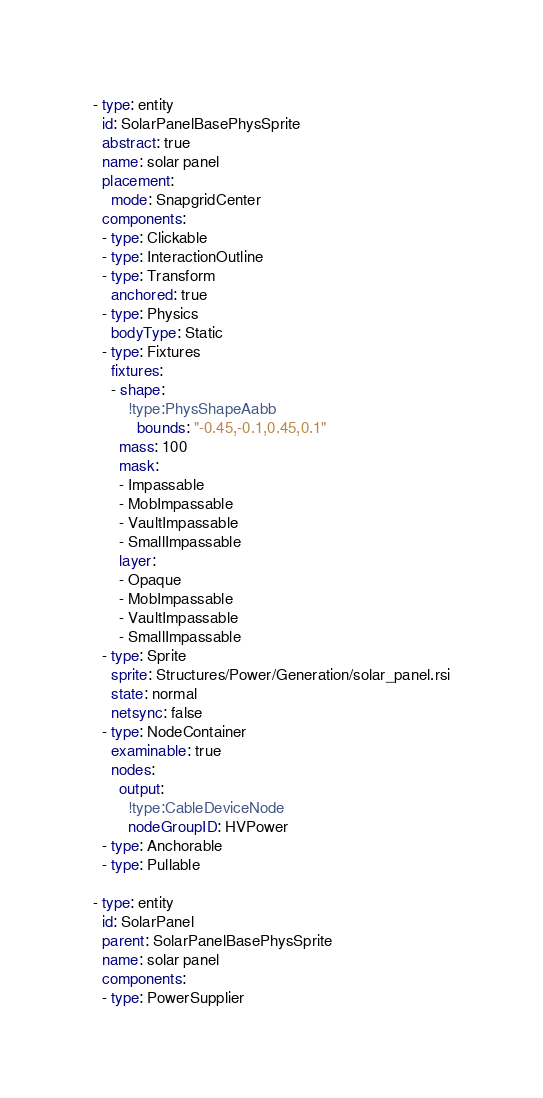<code> <loc_0><loc_0><loc_500><loc_500><_YAML_>- type: entity
  id: SolarPanelBasePhysSprite
  abstract: true
  name: solar panel
  placement:
    mode: SnapgridCenter
  components:
  - type: Clickable
  - type: InteractionOutline
  - type: Transform
    anchored: true
  - type: Physics
    bodyType: Static
  - type: Fixtures
    fixtures:
    - shape:
        !type:PhysShapeAabb
          bounds: "-0.45,-0.1,0.45,0.1"
      mass: 100
      mask:
      - Impassable
      - MobImpassable
      - VaultImpassable
      - SmallImpassable
      layer:
      - Opaque
      - MobImpassable
      - VaultImpassable
      - SmallImpassable
  - type: Sprite
    sprite: Structures/Power/Generation/solar_panel.rsi
    state: normal
    netsync: false
  - type: NodeContainer
    examinable: true
    nodes:
      output:
        !type:CableDeviceNode
        nodeGroupID: HVPower
  - type: Anchorable
  - type: Pullable

- type: entity
  id: SolarPanel
  parent: SolarPanelBasePhysSprite
  name: solar panel
  components:
  - type: PowerSupplier</code> 